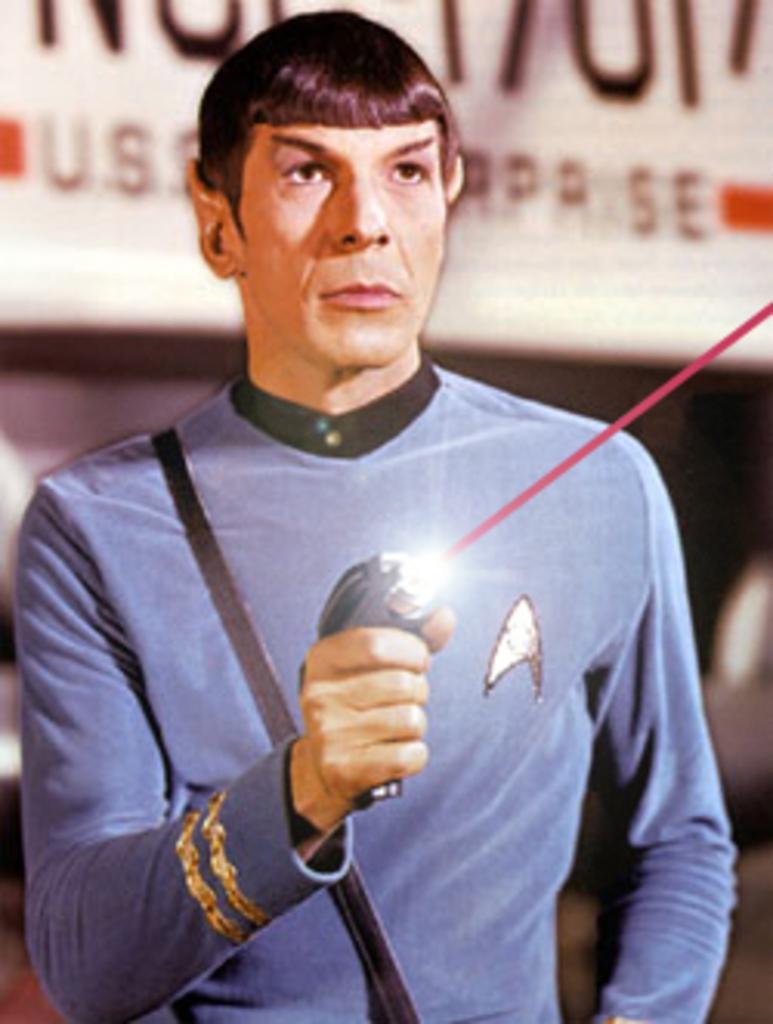In one or two sentences, can you explain what this image depicts? In the center of the image there is a person holding a laser gun. 